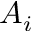Convert formula to latex. <formula><loc_0><loc_0><loc_500><loc_500>A _ { i }</formula> 